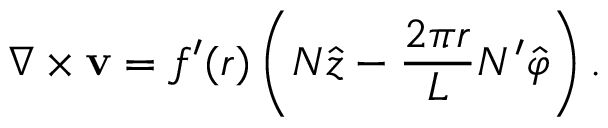Convert formula to latex. <formula><loc_0><loc_0><loc_500><loc_500>\nabla \times { v } = f ^ { \prime } ( r ) \left ( N \hat { z } - \frac { 2 \pi r } L N ^ { \prime } \hat { \varphi } \right ) .</formula> 